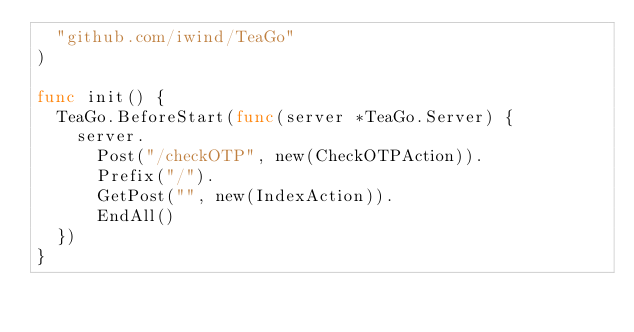<code> <loc_0><loc_0><loc_500><loc_500><_Go_>	"github.com/iwind/TeaGo"
)

func init() {
	TeaGo.BeforeStart(func(server *TeaGo.Server) {
		server.
			Post("/checkOTP", new(CheckOTPAction)).
			Prefix("/").
			GetPost("", new(IndexAction)).
			EndAll()
	})
}
</code> 